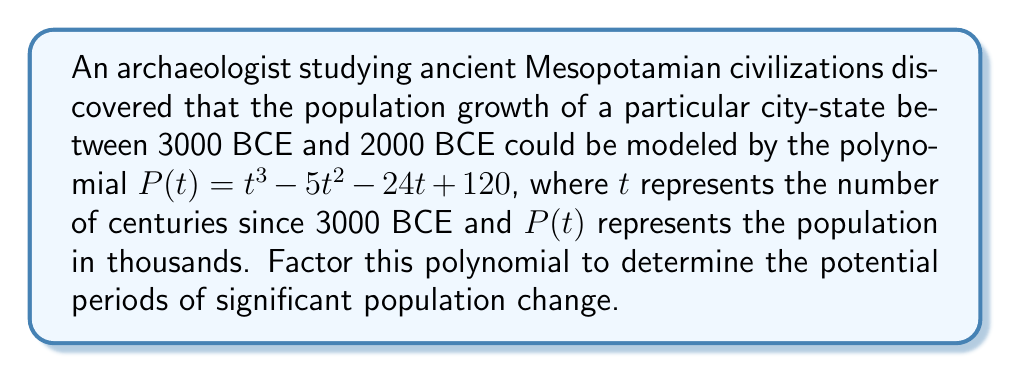Provide a solution to this math problem. To factor this polynomial, we'll follow these steps:

1) First, let's check if there are any rational roots using the rational root theorem. The possible rational roots are the factors of the constant term: ±1, ±2, ±3, ±4, ±5, ±6, ±8, ±10, ±12, ±15, ±20, ±24, ±30, ±40, ±60, ±120.

2) Testing these values, we find that $t = 8$ is a root of the polynomial.

3) We can now use polynomial long division to divide $P(t)$ by $(t - 8)$:

   $$t^3 - 5t^2 - 24t + 120 = (t - 8)(t^2 + 3t + 15)$$

4) Now we need to factor the quadratic term $t^2 + 3t + 15$. We can use the quadratic formula or try to factor by grouping.

5) The discriminant of this quadratic is $b^2 - 4ac = 3^2 - 4(1)(15) = -51$, which is negative. This means the quadratic has no real roots.

6) Therefore, $t^2 + 3t + 15$ cannot be factored further over the real numbers.

Thus, the complete factorization of the polynomial is:

$$P(t) = (t - 8)(t^2 + 3t + 15)$$

Historically, this factorization suggests that a significant population change may have occurred around 2200 BCE (8 centuries after 3000 BCE), possibly due to factors like technological advancements, climate changes, or political shifts in ancient Mesopotamia.
Answer: $P(t) = (t - 8)(t^2 + 3t + 15)$ 